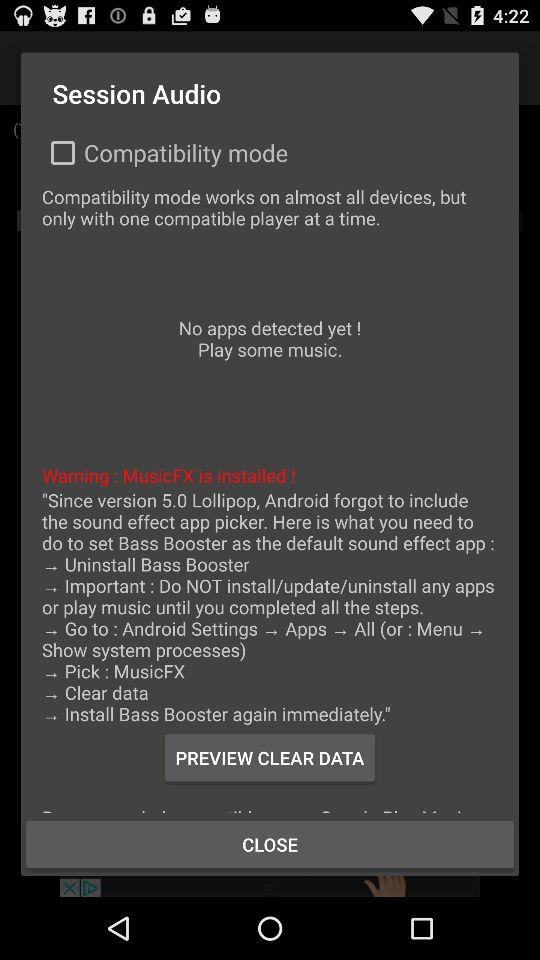How many steps are there in the instructions?
Answer the question using a single word or phrase. 6 